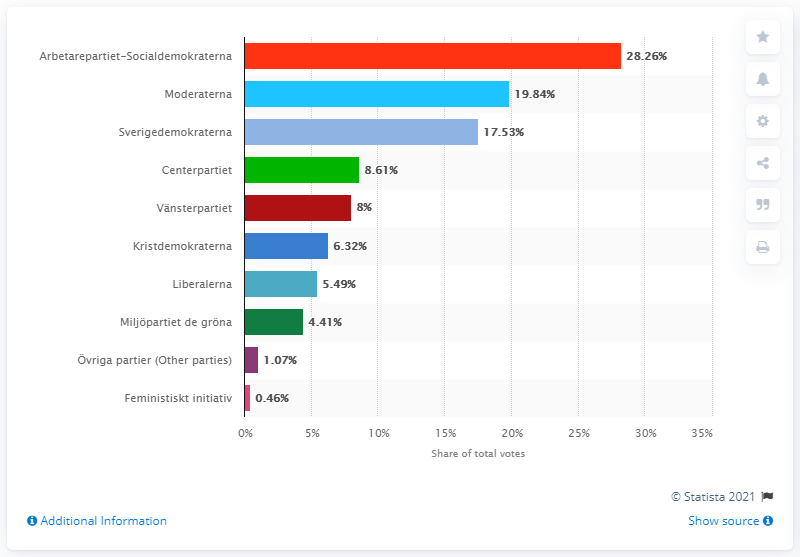Indicate a few pertinent items in this graphic. The largest party in parliament with 28.26% of the votes was Arbetarepartiet-Socialdemokraterna. Moderaterna received 19.84 percent of the votes in the election, placing them in second place. In the most recent election, the Sweden Democrats received 17.53% of the total votes cast. 